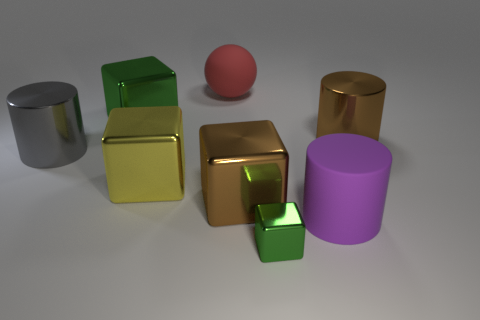Do the large red ball and the green block behind the small green cube have the same material?
Make the answer very short. No. What shape is the large matte thing to the right of the green metallic block that is in front of the gray shiny cylinder?
Offer a very short reply. Cylinder. What shape is the object that is both in front of the big red rubber object and behind the brown metallic cylinder?
Provide a succinct answer. Cube. How many things are large blue cubes or cylinders that are left of the purple thing?
Provide a succinct answer. 1. There is a brown object that is the same shape as the yellow thing; what is it made of?
Provide a short and direct response. Metal. There is a cylinder that is both on the right side of the yellow shiny thing and behind the big brown metal cube; what is it made of?
Give a very brief answer. Metal. What number of large green things have the same shape as the gray thing?
Provide a short and direct response. 0. What is the color of the object that is behind the green shiny object that is behind the brown metallic cylinder?
Your response must be concise. Red. Is the number of yellow metallic things behind the big green thing the same as the number of big metallic cylinders?
Offer a terse response. No. Are there any red cylinders of the same size as the purple object?
Give a very brief answer. No. 